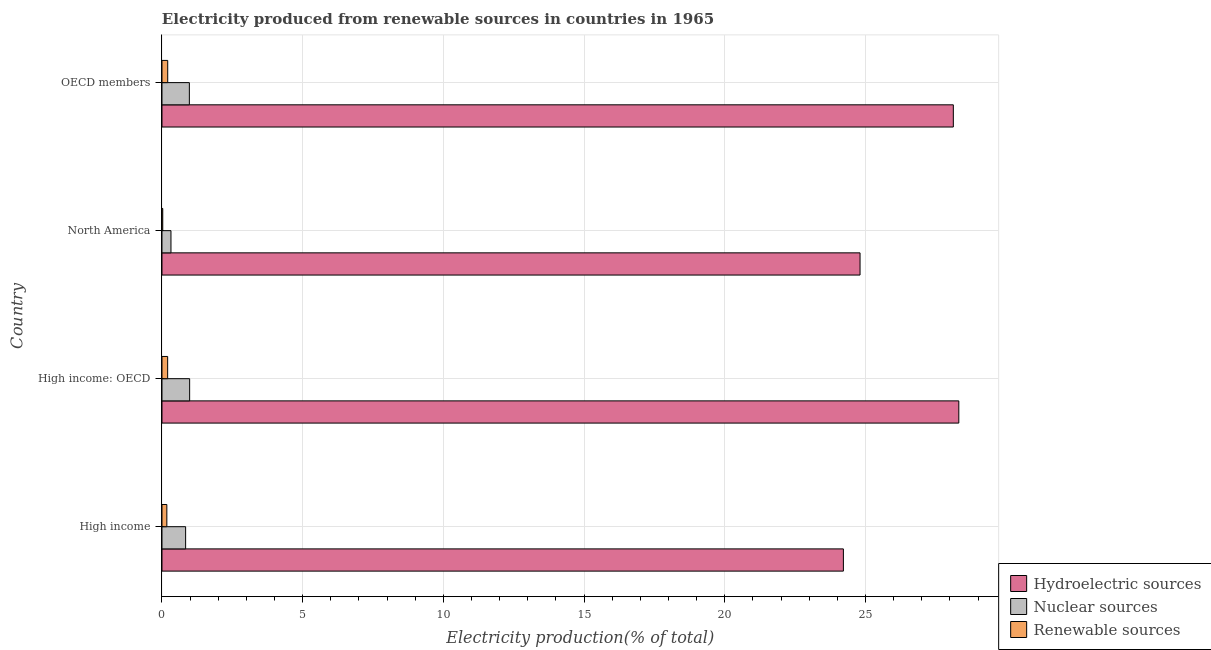How many different coloured bars are there?
Your response must be concise. 3. How many groups of bars are there?
Provide a short and direct response. 4. How many bars are there on the 2nd tick from the top?
Give a very brief answer. 3. What is the label of the 1st group of bars from the top?
Keep it short and to the point. OECD members. What is the percentage of electricity produced by renewable sources in OECD members?
Your answer should be very brief. 0.2. Across all countries, what is the maximum percentage of electricity produced by nuclear sources?
Provide a succinct answer. 0.98. Across all countries, what is the minimum percentage of electricity produced by hydroelectric sources?
Make the answer very short. 24.22. In which country was the percentage of electricity produced by hydroelectric sources maximum?
Ensure brevity in your answer.  High income: OECD. In which country was the percentage of electricity produced by nuclear sources minimum?
Offer a terse response. North America. What is the total percentage of electricity produced by hydroelectric sources in the graph?
Provide a succinct answer. 105.46. What is the difference between the percentage of electricity produced by renewable sources in High income: OECD and that in North America?
Offer a very short reply. 0.17. What is the difference between the percentage of electricity produced by hydroelectric sources in OECD members and the percentage of electricity produced by nuclear sources in North America?
Ensure brevity in your answer.  27.8. What is the average percentage of electricity produced by renewable sources per country?
Offer a terse response. 0.15. What is the difference between the percentage of electricity produced by renewable sources and percentage of electricity produced by nuclear sources in High income: OECD?
Keep it short and to the point. -0.78. What is the ratio of the percentage of electricity produced by hydroelectric sources in High income to that in OECD members?
Give a very brief answer. 0.86. Is the percentage of electricity produced by nuclear sources in High income less than that in OECD members?
Offer a very short reply. Yes. Is the difference between the percentage of electricity produced by nuclear sources in High income and North America greater than the difference between the percentage of electricity produced by renewable sources in High income and North America?
Give a very brief answer. Yes. What is the difference between the highest and the second highest percentage of electricity produced by renewable sources?
Provide a succinct answer. 0. What is the difference between the highest and the lowest percentage of electricity produced by renewable sources?
Make the answer very short. 0.18. In how many countries, is the percentage of electricity produced by hydroelectric sources greater than the average percentage of electricity produced by hydroelectric sources taken over all countries?
Provide a succinct answer. 2. Is the sum of the percentage of electricity produced by nuclear sources in North America and OECD members greater than the maximum percentage of electricity produced by hydroelectric sources across all countries?
Ensure brevity in your answer.  No. What does the 2nd bar from the top in North America represents?
Ensure brevity in your answer.  Nuclear sources. What does the 1st bar from the bottom in High income: OECD represents?
Ensure brevity in your answer.  Hydroelectric sources. Is it the case that in every country, the sum of the percentage of electricity produced by hydroelectric sources and percentage of electricity produced by nuclear sources is greater than the percentage of electricity produced by renewable sources?
Ensure brevity in your answer.  Yes. How many bars are there?
Provide a succinct answer. 12. Does the graph contain any zero values?
Make the answer very short. No. How many legend labels are there?
Your answer should be compact. 3. What is the title of the graph?
Your response must be concise. Electricity produced from renewable sources in countries in 1965. What is the Electricity production(% of total) in Hydroelectric sources in High income?
Provide a succinct answer. 24.22. What is the Electricity production(% of total) of Nuclear sources in High income?
Provide a succinct answer. 0.84. What is the Electricity production(% of total) of Renewable sources in High income?
Provide a short and direct response. 0.17. What is the Electricity production(% of total) in Hydroelectric sources in High income: OECD?
Your response must be concise. 28.32. What is the Electricity production(% of total) in Nuclear sources in High income: OECD?
Keep it short and to the point. 0.98. What is the Electricity production(% of total) in Renewable sources in High income: OECD?
Make the answer very short. 0.2. What is the Electricity production(% of total) of Hydroelectric sources in North America?
Ensure brevity in your answer.  24.81. What is the Electricity production(% of total) of Nuclear sources in North America?
Keep it short and to the point. 0.32. What is the Electricity production(% of total) in Renewable sources in North America?
Make the answer very short. 0.03. What is the Electricity production(% of total) of Hydroelectric sources in OECD members?
Provide a succinct answer. 28.12. What is the Electricity production(% of total) of Nuclear sources in OECD members?
Your answer should be compact. 0.97. What is the Electricity production(% of total) in Renewable sources in OECD members?
Offer a terse response. 0.2. Across all countries, what is the maximum Electricity production(% of total) in Hydroelectric sources?
Provide a short and direct response. 28.32. Across all countries, what is the maximum Electricity production(% of total) in Nuclear sources?
Your answer should be compact. 0.98. Across all countries, what is the maximum Electricity production(% of total) in Renewable sources?
Your answer should be compact. 0.2. Across all countries, what is the minimum Electricity production(% of total) in Hydroelectric sources?
Your answer should be very brief. 24.22. Across all countries, what is the minimum Electricity production(% of total) of Nuclear sources?
Your answer should be very brief. 0.32. Across all countries, what is the minimum Electricity production(% of total) of Renewable sources?
Give a very brief answer. 0.03. What is the total Electricity production(% of total) in Hydroelectric sources in the graph?
Offer a terse response. 105.46. What is the total Electricity production(% of total) in Nuclear sources in the graph?
Your response must be concise. 3.11. What is the total Electricity production(% of total) of Renewable sources in the graph?
Your response must be concise. 0.6. What is the difference between the Electricity production(% of total) of Hydroelectric sources in High income and that in High income: OECD?
Keep it short and to the point. -4.1. What is the difference between the Electricity production(% of total) in Nuclear sources in High income and that in High income: OECD?
Offer a terse response. -0.14. What is the difference between the Electricity production(% of total) in Renewable sources in High income and that in High income: OECD?
Your response must be concise. -0.03. What is the difference between the Electricity production(% of total) in Hydroelectric sources in High income and that in North America?
Ensure brevity in your answer.  -0.59. What is the difference between the Electricity production(% of total) of Nuclear sources in High income and that in North America?
Make the answer very short. 0.52. What is the difference between the Electricity production(% of total) of Renewable sources in High income and that in North America?
Offer a very short reply. 0.15. What is the difference between the Electricity production(% of total) of Hydroelectric sources in High income and that in OECD members?
Ensure brevity in your answer.  -3.91. What is the difference between the Electricity production(% of total) in Nuclear sources in High income and that in OECD members?
Keep it short and to the point. -0.13. What is the difference between the Electricity production(% of total) in Renewable sources in High income and that in OECD members?
Offer a terse response. -0.03. What is the difference between the Electricity production(% of total) in Hydroelectric sources in High income: OECD and that in North America?
Provide a short and direct response. 3.51. What is the difference between the Electricity production(% of total) of Nuclear sources in High income: OECD and that in North America?
Ensure brevity in your answer.  0.66. What is the difference between the Electricity production(% of total) in Renewable sources in High income: OECD and that in North America?
Give a very brief answer. 0.17. What is the difference between the Electricity production(% of total) in Hydroelectric sources in High income: OECD and that in OECD members?
Provide a succinct answer. 0.19. What is the difference between the Electricity production(% of total) of Nuclear sources in High income: OECD and that in OECD members?
Give a very brief answer. 0.01. What is the difference between the Electricity production(% of total) of Renewable sources in High income: OECD and that in OECD members?
Your answer should be compact. -0. What is the difference between the Electricity production(% of total) of Hydroelectric sources in North America and that in OECD members?
Offer a very short reply. -3.31. What is the difference between the Electricity production(% of total) in Nuclear sources in North America and that in OECD members?
Ensure brevity in your answer.  -0.65. What is the difference between the Electricity production(% of total) of Renewable sources in North America and that in OECD members?
Give a very brief answer. -0.18. What is the difference between the Electricity production(% of total) in Hydroelectric sources in High income and the Electricity production(% of total) in Nuclear sources in High income: OECD?
Your response must be concise. 23.23. What is the difference between the Electricity production(% of total) in Hydroelectric sources in High income and the Electricity production(% of total) in Renewable sources in High income: OECD?
Give a very brief answer. 24.01. What is the difference between the Electricity production(% of total) in Nuclear sources in High income and the Electricity production(% of total) in Renewable sources in High income: OECD?
Your answer should be very brief. 0.64. What is the difference between the Electricity production(% of total) of Hydroelectric sources in High income and the Electricity production(% of total) of Nuclear sources in North America?
Ensure brevity in your answer.  23.9. What is the difference between the Electricity production(% of total) in Hydroelectric sources in High income and the Electricity production(% of total) in Renewable sources in North America?
Offer a terse response. 24.19. What is the difference between the Electricity production(% of total) of Nuclear sources in High income and the Electricity production(% of total) of Renewable sources in North America?
Your answer should be very brief. 0.81. What is the difference between the Electricity production(% of total) of Hydroelectric sources in High income and the Electricity production(% of total) of Nuclear sources in OECD members?
Ensure brevity in your answer.  23.24. What is the difference between the Electricity production(% of total) of Hydroelectric sources in High income and the Electricity production(% of total) of Renewable sources in OECD members?
Your response must be concise. 24.01. What is the difference between the Electricity production(% of total) of Nuclear sources in High income and the Electricity production(% of total) of Renewable sources in OECD members?
Keep it short and to the point. 0.64. What is the difference between the Electricity production(% of total) in Hydroelectric sources in High income: OECD and the Electricity production(% of total) in Nuclear sources in North America?
Offer a terse response. 28. What is the difference between the Electricity production(% of total) of Hydroelectric sources in High income: OECD and the Electricity production(% of total) of Renewable sources in North America?
Provide a succinct answer. 28.29. What is the difference between the Electricity production(% of total) of Nuclear sources in High income: OECD and the Electricity production(% of total) of Renewable sources in North America?
Provide a succinct answer. 0.96. What is the difference between the Electricity production(% of total) of Hydroelectric sources in High income: OECD and the Electricity production(% of total) of Nuclear sources in OECD members?
Your answer should be very brief. 27.34. What is the difference between the Electricity production(% of total) of Hydroelectric sources in High income: OECD and the Electricity production(% of total) of Renewable sources in OECD members?
Provide a short and direct response. 28.11. What is the difference between the Electricity production(% of total) of Nuclear sources in High income: OECD and the Electricity production(% of total) of Renewable sources in OECD members?
Keep it short and to the point. 0.78. What is the difference between the Electricity production(% of total) in Hydroelectric sources in North America and the Electricity production(% of total) in Nuclear sources in OECD members?
Provide a short and direct response. 23.84. What is the difference between the Electricity production(% of total) in Hydroelectric sources in North America and the Electricity production(% of total) in Renewable sources in OECD members?
Ensure brevity in your answer.  24.6. What is the difference between the Electricity production(% of total) in Nuclear sources in North America and the Electricity production(% of total) in Renewable sources in OECD members?
Provide a short and direct response. 0.12. What is the average Electricity production(% of total) in Hydroelectric sources per country?
Give a very brief answer. 26.37. What is the average Electricity production(% of total) in Nuclear sources per country?
Your answer should be very brief. 0.78. What is the average Electricity production(% of total) of Renewable sources per country?
Offer a terse response. 0.15. What is the difference between the Electricity production(% of total) in Hydroelectric sources and Electricity production(% of total) in Nuclear sources in High income?
Offer a very short reply. 23.38. What is the difference between the Electricity production(% of total) of Hydroelectric sources and Electricity production(% of total) of Renewable sources in High income?
Give a very brief answer. 24.04. What is the difference between the Electricity production(% of total) of Nuclear sources and Electricity production(% of total) of Renewable sources in High income?
Give a very brief answer. 0.67. What is the difference between the Electricity production(% of total) of Hydroelectric sources and Electricity production(% of total) of Nuclear sources in High income: OECD?
Offer a terse response. 27.33. What is the difference between the Electricity production(% of total) of Hydroelectric sources and Electricity production(% of total) of Renewable sources in High income: OECD?
Provide a succinct answer. 28.12. What is the difference between the Electricity production(% of total) in Nuclear sources and Electricity production(% of total) in Renewable sources in High income: OECD?
Offer a very short reply. 0.78. What is the difference between the Electricity production(% of total) of Hydroelectric sources and Electricity production(% of total) of Nuclear sources in North America?
Provide a succinct answer. 24.49. What is the difference between the Electricity production(% of total) in Hydroelectric sources and Electricity production(% of total) in Renewable sources in North America?
Provide a succinct answer. 24.78. What is the difference between the Electricity production(% of total) in Nuclear sources and Electricity production(% of total) in Renewable sources in North America?
Make the answer very short. 0.29. What is the difference between the Electricity production(% of total) in Hydroelectric sources and Electricity production(% of total) in Nuclear sources in OECD members?
Ensure brevity in your answer.  27.15. What is the difference between the Electricity production(% of total) of Hydroelectric sources and Electricity production(% of total) of Renewable sources in OECD members?
Ensure brevity in your answer.  27.92. What is the difference between the Electricity production(% of total) in Nuclear sources and Electricity production(% of total) in Renewable sources in OECD members?
Your answer should be very brief. 0.77. What is the ratio of the Electricity production(% of total) in Hydroelectric sources in High income to that in High income: OECD?
Provide a short and direct response. 0.86. What is the ratio of the Electricity production(% of total) of Nuclear sources in High income to that in High income: OECD?
Make the answer very short. 0.86. What is the ratio of the Electricity production(% of total) of Renewable sources in High income to that in High income: OECD?
Provide a succinct answer. 0.86. What is the ratio of the Electricity production(% of total) of Hydroelectric sources in High income to that in North America?
Ensure brevity in your answer.  0.98. What is the ratio of the Electricity production(% of total) in Nuclear sources in High income to that in North America?
Provide a short and direct response. 2.63. What is the ratio of the Electricity production(% of total) of Renewable sources in High income to that in North America?
Give a very brief answer. 6.32. What is the ratio of the Electricity production(% of total) of Hydroelectric sources in High income to that in OECD members?
Offer a terse response. 0.86. What is the ratio of the Electricity production(% of total) of Nuclear sources in High income to that in OECD members?
Make the answer very short. 0.86. What is the ratio of the Electricity production(% of total) of Renewable sources in High income to that in OECD members?
Make the answer very short. 0.85. What is the ratio of the Electricity production(% of total) of Hydroelectric sources in High income: OECD to that in North America?
Your answer should be compact. 1.14. What is the ratio of the Electricity production(% of total) of Nuclear sources in High income: OECD to that in North America?
Give a very brief answer. 3.08. What is the ratio of the Electricity production(% of total) of Renewable sources in High income: OECD to that in North America?
Your response must be concise. 7.4. What is the ratio of the Electricity production(% of total) in Hydroelectric sources in North America to that in OECD members?
Offer a very short reply. 0.88. What is the ratio of the Electricity production(% of total) in Nuclear sources in North America to that in OECD members?
Your answer should be very brief. 0.33. What is the ratio of the Electricity production(% of total) of Renewable sources in North America to that in OECD members?
Offer a very short reply. 0.13. What is the difference between the highest and the second highest Electricity production(% of total) in Hydroelectric sources?
Make the answer very short. 0.19. What is the difference between the highest and the second highest Electricity production(% of total) of Nuclear sources?
Your answer should be compact. 0.01. What is the difference between the highest and the second highest Electricity production(% of total) of Renewable sources?
Your response must be concise. 0. What is the difference between the highest and the lowest Electricity production(% of total) in Hydroelectric sources?
Offer a terse response. 4.1. What is the difference between the highest and the lowest Electricity production(% of total) of Nuclear sources?
Ensure brevity in your answer.  0.66. What is the difference between the highest and the lowest Electricity production(% of total) in Renewable sources?
Keep it short and to the point. 0.18. 